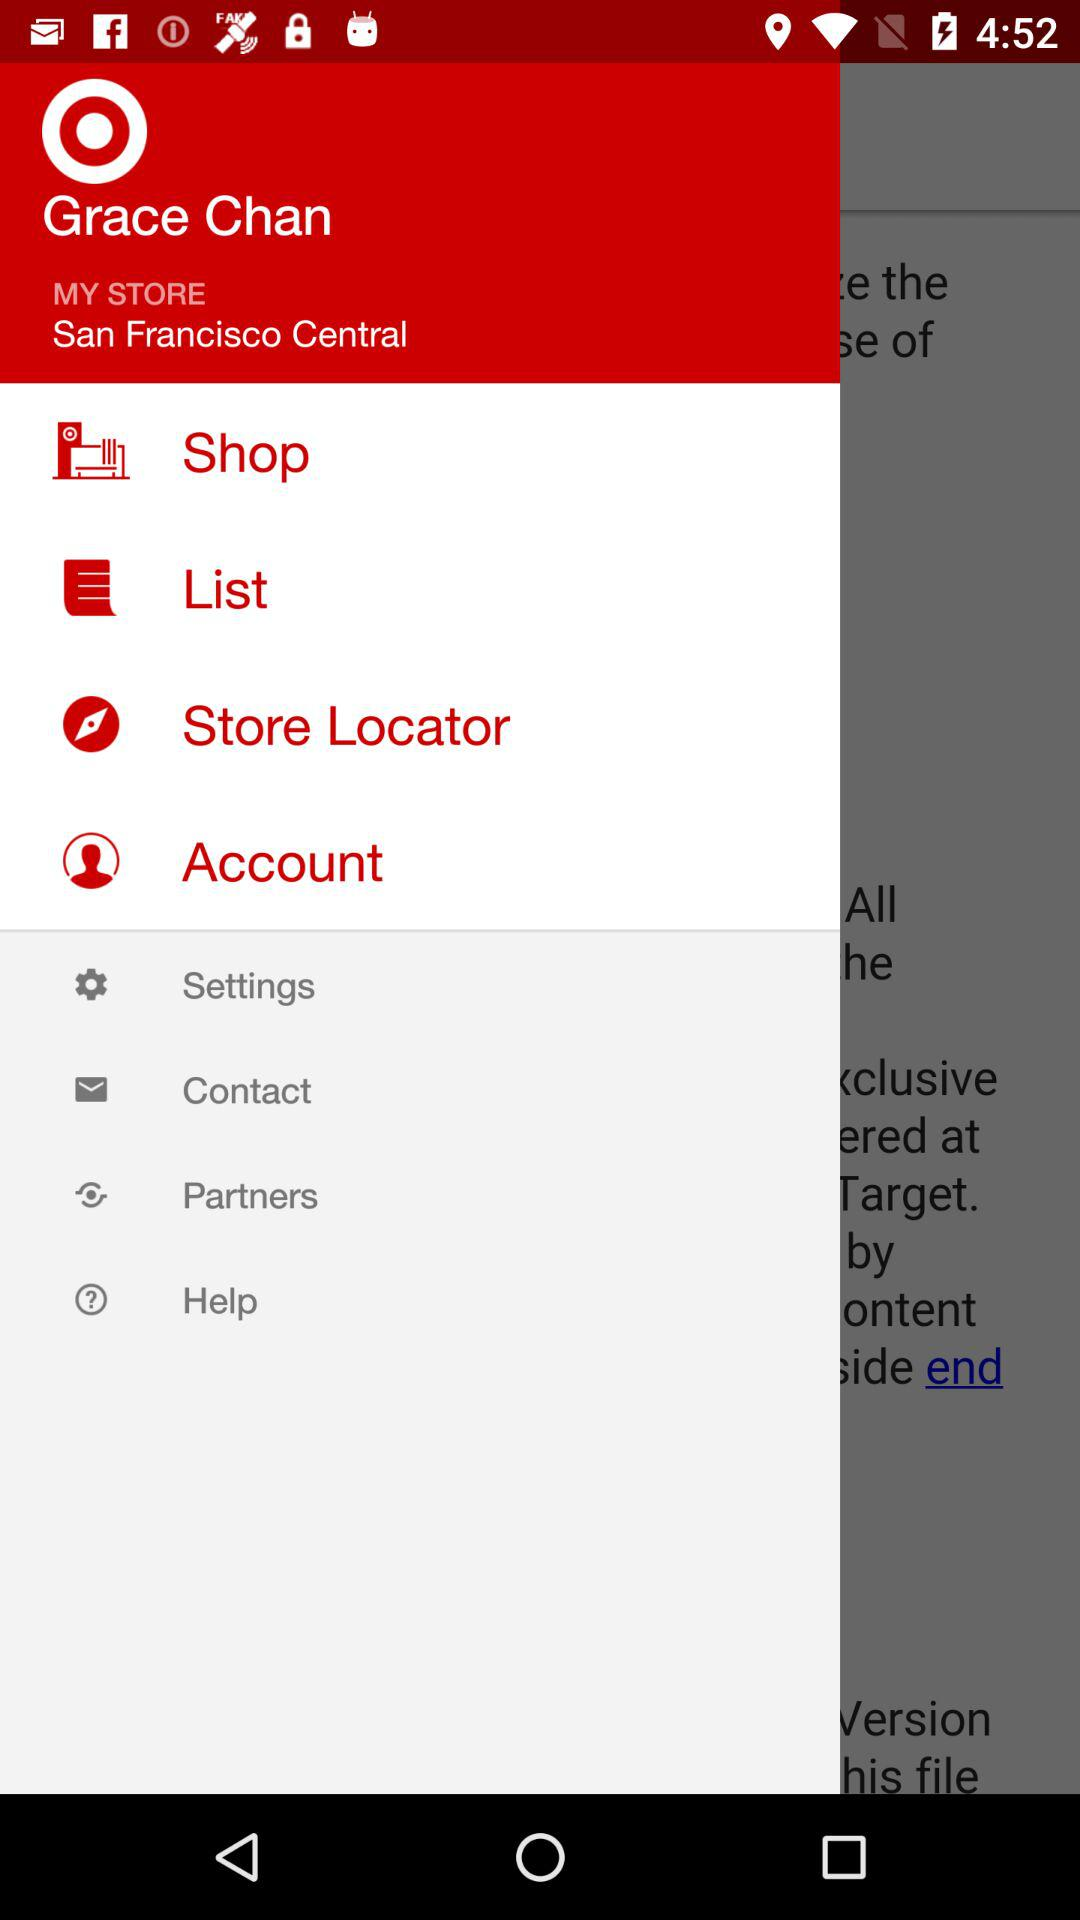What is the name of the user? The name of the user is Grace Chan. 